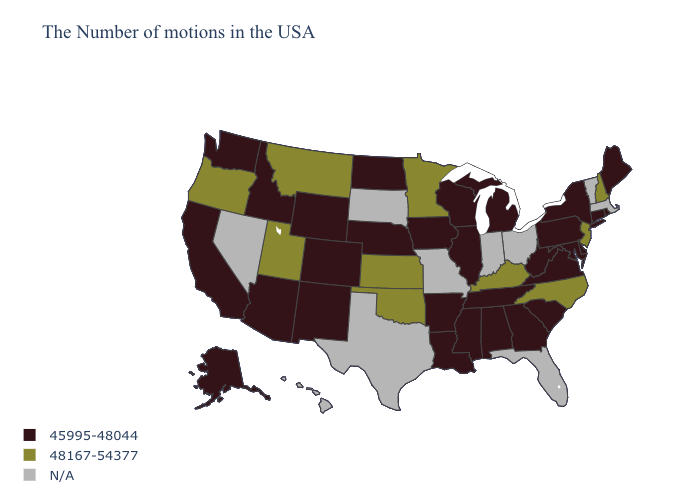Among the states that border Kansas , which have the highest value?
Keep it brief. Oklahoma. Which states have the lowest value in the Northeast?
Short answer required. Maine, Rhode Island, Connecticut, New York, Pennsylvania. Does Oregon have the lowest value in the USA?
Write a very short answer. No. Which states have the lowest value in the MidWest?
Be succinct. Michigan, Wisconsin, Illinois, Iowa, Nebraska, North Dakota. Name the states that have a value in the range 45995-48044?
Write a very short answer. Maine, Rhode Island, Connecticut, New York, Delaware, Maryland, Pennsylvania, Virginia, South Carolina, West Virginia, Georgia, Michigan, Alabama, Tennessee, Wisconsin, Illinois, Mississippi, Louisiana, Arkansas, Iowa, Nebraska, North Dakota, Wyoming, Colorado, New Mexico, Arizona, Idaho, California, Washington, Alaska. Does the first symbol in the legend represent the smallest category?
Keep it brief. Yes. Is the legend a continuous bar?
Concise answer only. No. Does Kentucky have the highest value in the USA?
Be succinct. Yes. What is the highest value in the South ?
Keep it brief. 48167-54377. Which states hav the highest value in the Northeast?
Be succinct. New Hampshire, New Jersey. What is the highest value in the MidWest ?
Write a very short answer. 48167-54377. Among the states that border Utah , which have the highest value?
Give a very brief answer. Wyoming, Colorado, New Mexico, Arizona, Idaho. 